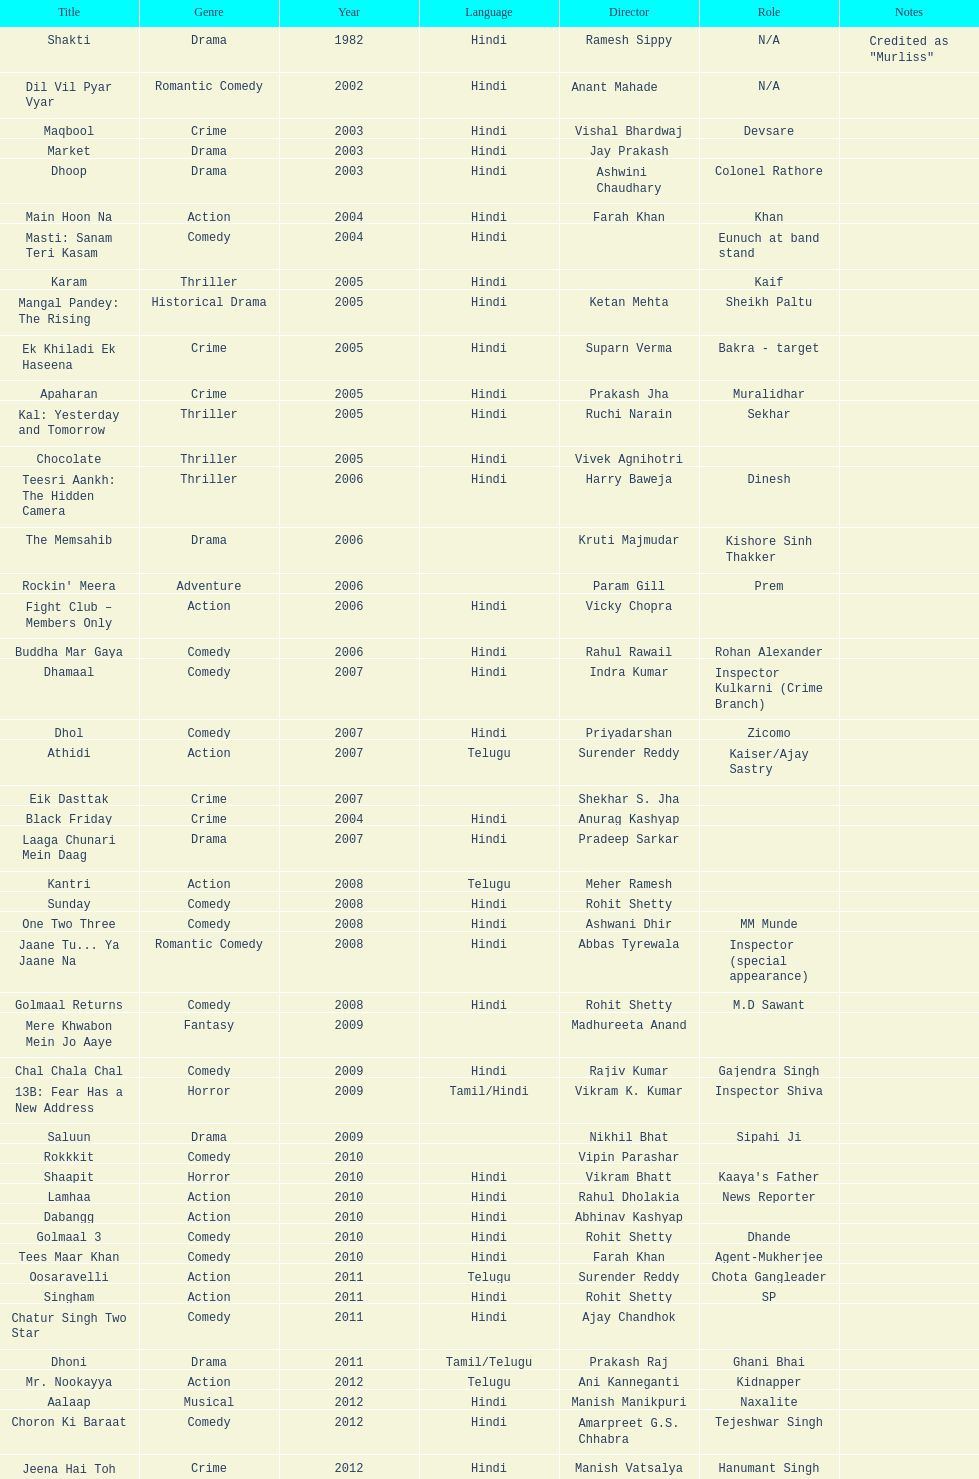How many roles has this actor had? 36. 